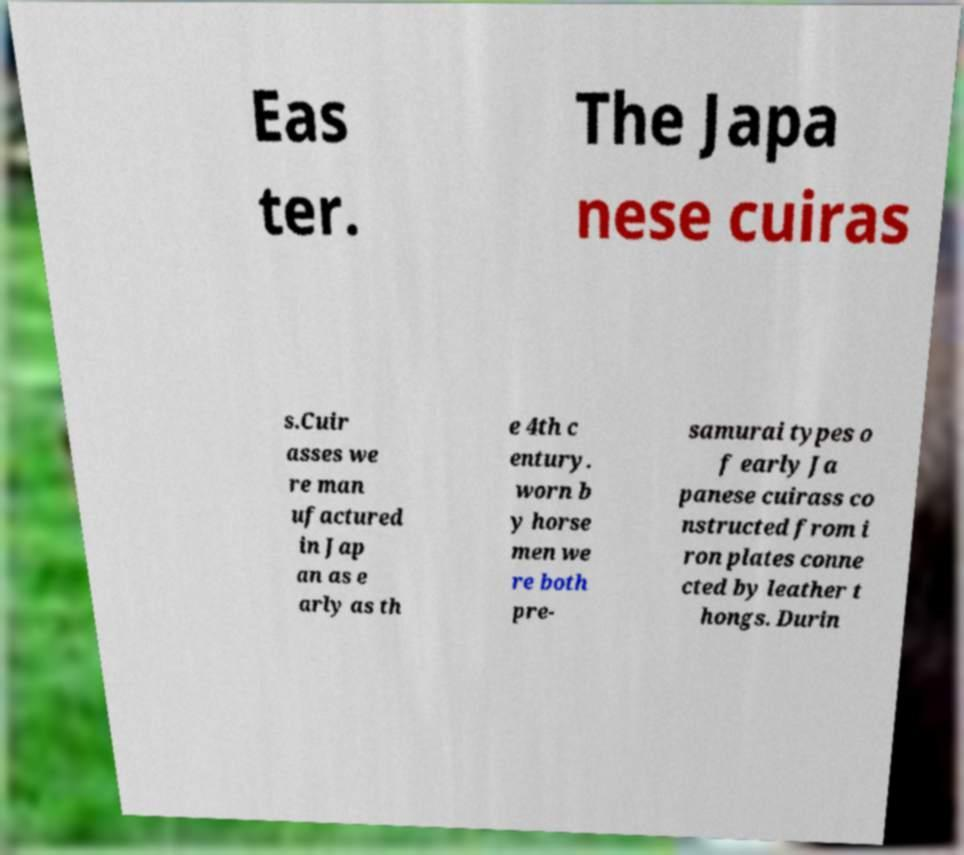Please read and relay the text visible in this image. What does it say? Eas ter. The Japa nese cuiras s.Cuir asses we re man ufactured in Jap an as e arly as th e 4th c entury. worn b y horse men we re both pre- samurai types o f early Ja panese cuirass co nstructed from i ron plates conne cted by leather t hongs. Durin 